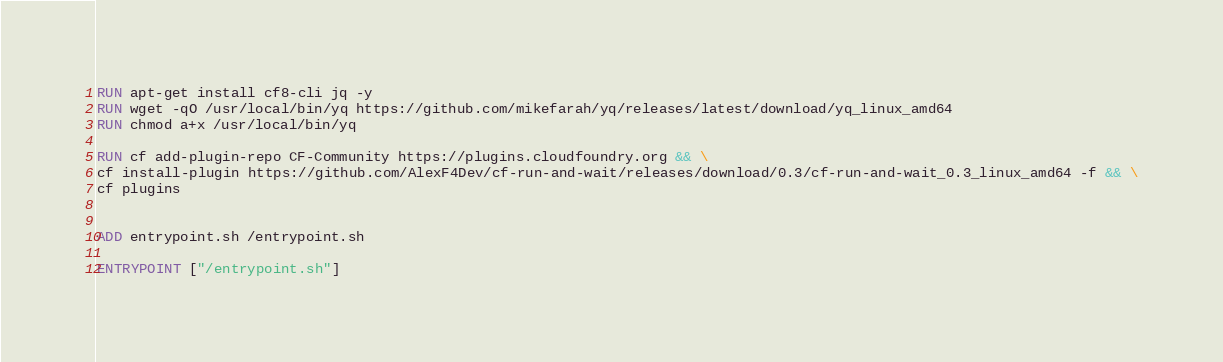Convert code to text. <code><loc_0><loc_0><loc_500><loc_500><_Dockerfile_>RUN apt-get install cf8-cli jq -y
RUN wget -qO /usr/local/bin/yq https://github.com/mikefarah/yq/releases/latest/download/yq_linux_amd64
RUN chmod a+x /usr/local/bin/yq

RUN cf add-plugin-repo CF-Community https://plugins.cloudfoundry.org && \
cf install-plugin https://github.com/AlexF4Dev/cf-run-and-wait/releases/download/0.3/cf-run-and-wait_0.3_linux_amd64 -f && \
cf plugins


ADD entrypoint.sh /entrypoint.sh

ENTRYPOINT ["/entrypoint.sh"]</code> 